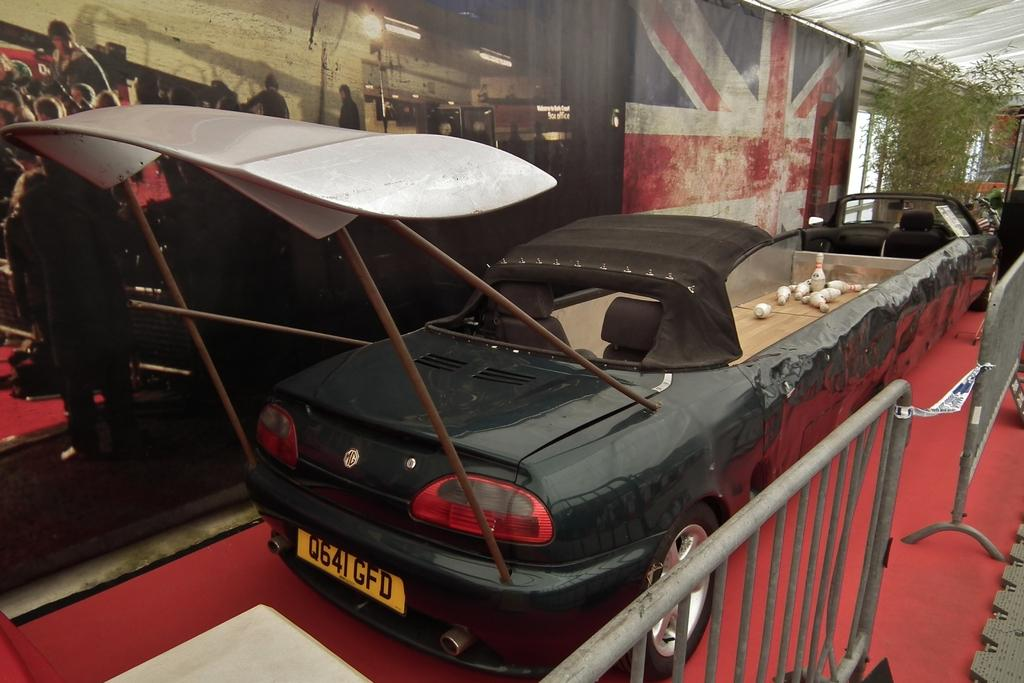What type of motor vehicle is in the image? There is a motor vehicle in the image, but the specific type is not mentioned. What type of vegetation is present in the image? Creepers are present in the image. How many persons are standing on the floor in the image? There are persons standing on the floor in the image, but the exact number is not mentioned. What type of lighting is visible in the image? Electric lights are visible in the image. What type of barrier is present in the image? Iron grills are present in the image. What type of floor covering is in the image? There is a carpet in the image. How does the judge in the image limit the vacation time for the persons standing on the floor? There is no judge or vacation mentioned in the image; it features a motor vehicle, creepers, persons standing on the floor, electric lights, iron grills, and a carpet. 